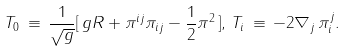Convert formula to latex. <formula><loc_0><loc_0><loc_500><loc_500>T _ { 0 } \, \equiv \, \frac { 1 } { \sqrt { g } } [ \, g R + \pi ^ { i j } \pi _ { i j } - \frac { 1 } { 2 } \pi ^ { 2 } \, ] , \, T _ { i } \, \equiv \, - 2 \nabla _ { j } \, \pi ^ { j } _ { i } .</formula> 